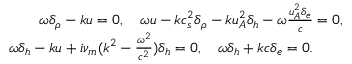<formula> <loc_0><loc_0><loc_500><loc_500>\begin{array} { r } { \omega \delta _ { \rho } - k u = 0 , \quad \omega u - k c _ { s } ^ { 2 } \delta _ { \rho } - k u _ { A } ^ { 2 } \delta _ { h } - \omega \frac { u _ { A } ^ { 2 } \delta _ { e } } { c } = 0 , } \\ { \omega \delta _ { h } - k u + i \nu _ { m } ( k ^ { 2 } - \frac { \omega ^ { 2 } } { c ^ { 2 } } ) \delta _ { h } = 0 , \quad \omega \delta _ { h } + k c \delta _ { e } = 0 . \quad } \end{array}</formula> 